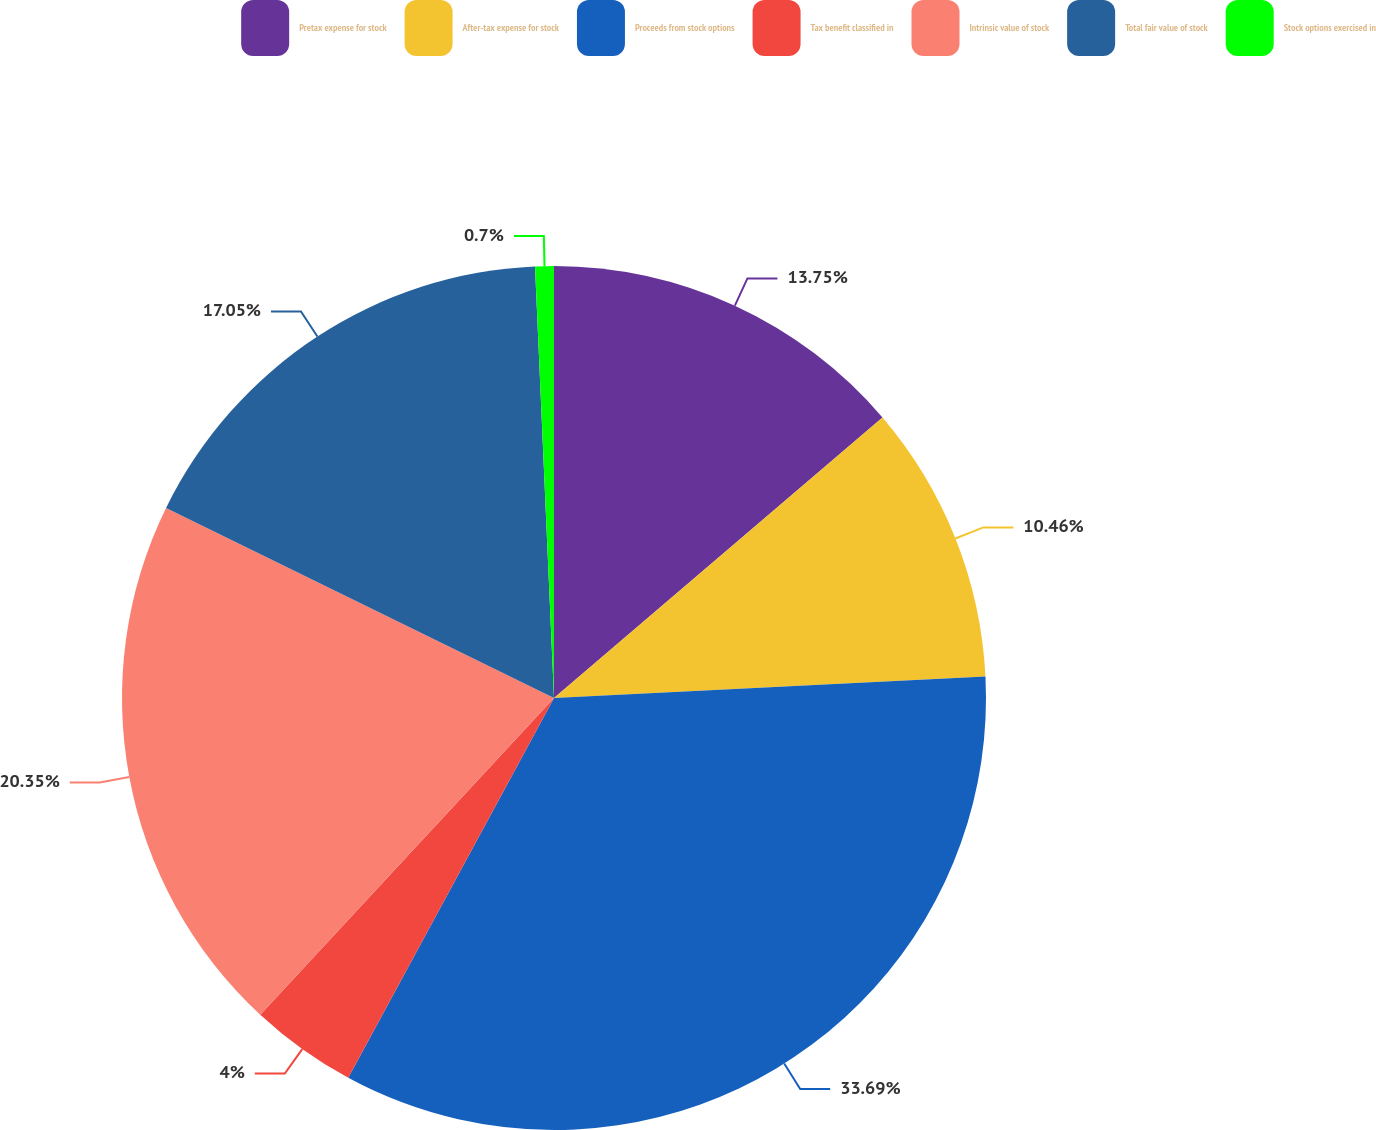Convert chart to OTSL. <chart><loc_0><loc_0><loc_500><loc_500><pie_chart><fcel>Pretax expense for stock<fcel>After-tax expense for stock<fcel>Proceeds from stock options<fcel>Tax benefit classified in<fcel>Intrinsic value of stock<fcel>Total fair value of stock<fcel>Stock options exercised in<nl><fcel>13.75%<fcel>10.46%<fcel>33.69%<fcel>4.0%<fcel>20.35%<fcel>17.05%<fcel>0.7%<nl></chart> 